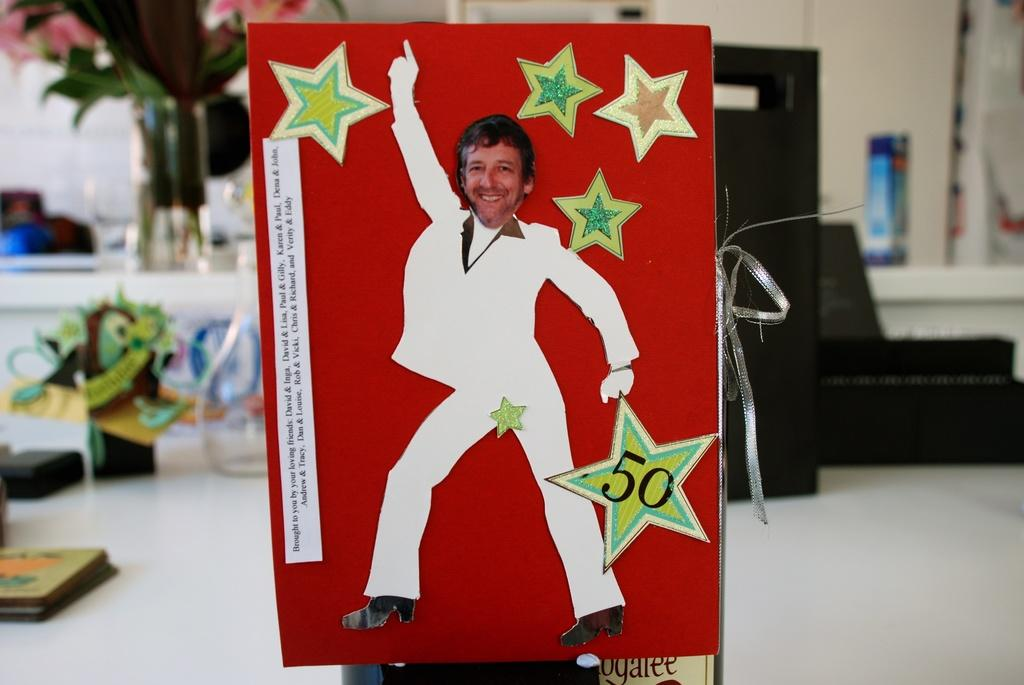What color is the prominent object in the image? The prominent object in the image is red. What is depicted on the red object? The red object has a picture of a person dancing. Can you describe any other objects visible in the image? There are other objects in the background of the image, but their details are not specified in the provided facts. Is there a zephyr blowing the person's hair in the dancing picture? There is no mention of a zephyr or any wind in the image, and the provided facts do not allow us to determine if the person's hair is being blown. 